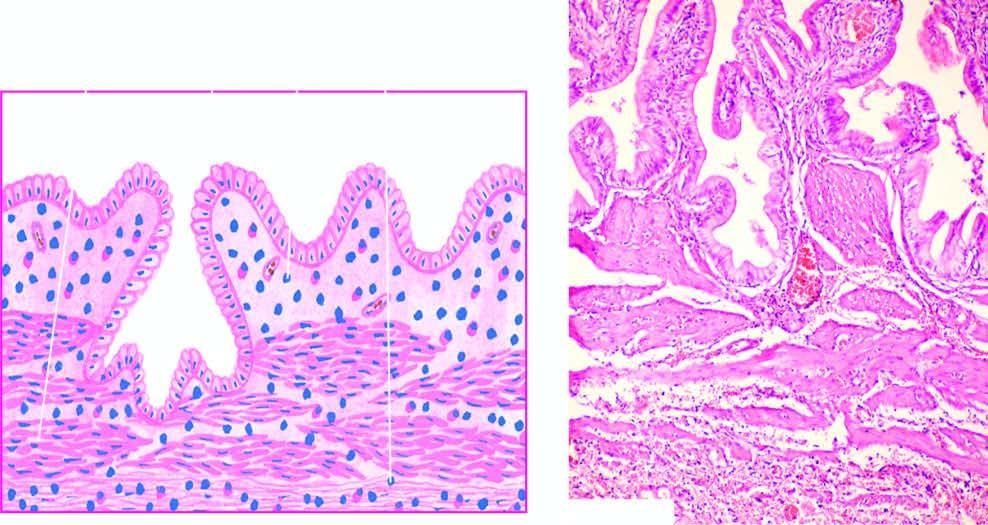where is mononuclear inflammatory cell infiltrate present?
Answer the question using a single word or phrase. In subepithelial and perimuscular layers 